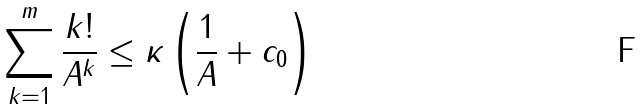<formula> <loc_0><loc_0><loc_500><loc_500>\sum _ { k = 1 } ^ { m } \frac { k ! } { A ^ { k } } \leq \kappa \left ( \frac { 1 } { A } + c _ { 0 } \right )</formula> 